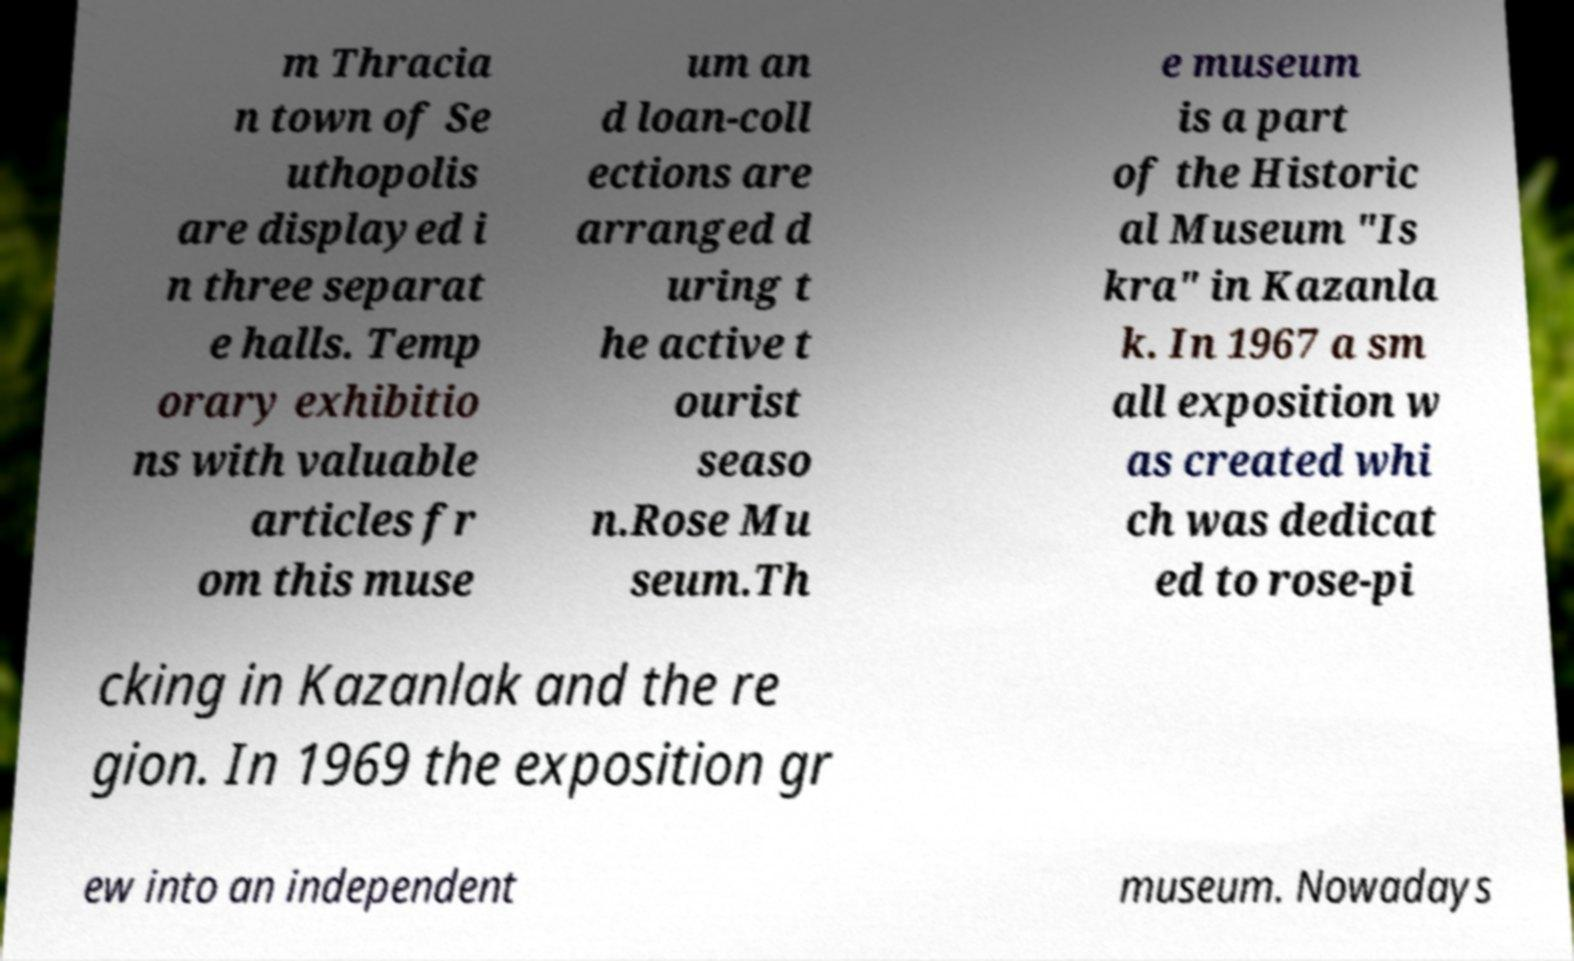There's text embedded in this image that I need extracted. Can you transcribe it verbatim? m Thracia n town of Se uthopolis are displayed i n three separat e halls. Temp orary exhibitio ns with valuable articles fr om this muse um an d loan-coll ections are arranged d uring t he active t ourist seaso n.Rose Mu seum.Th e museum is a part of the Historic al Museum "Is kra" in Kazanla k. In 1967 a sm all exposition w as created whi ch was dedicat ed to rose-pi cking in Kazanlak and the re gion. In 1969 the exposition gr ew into an independent museum. Nowadays 